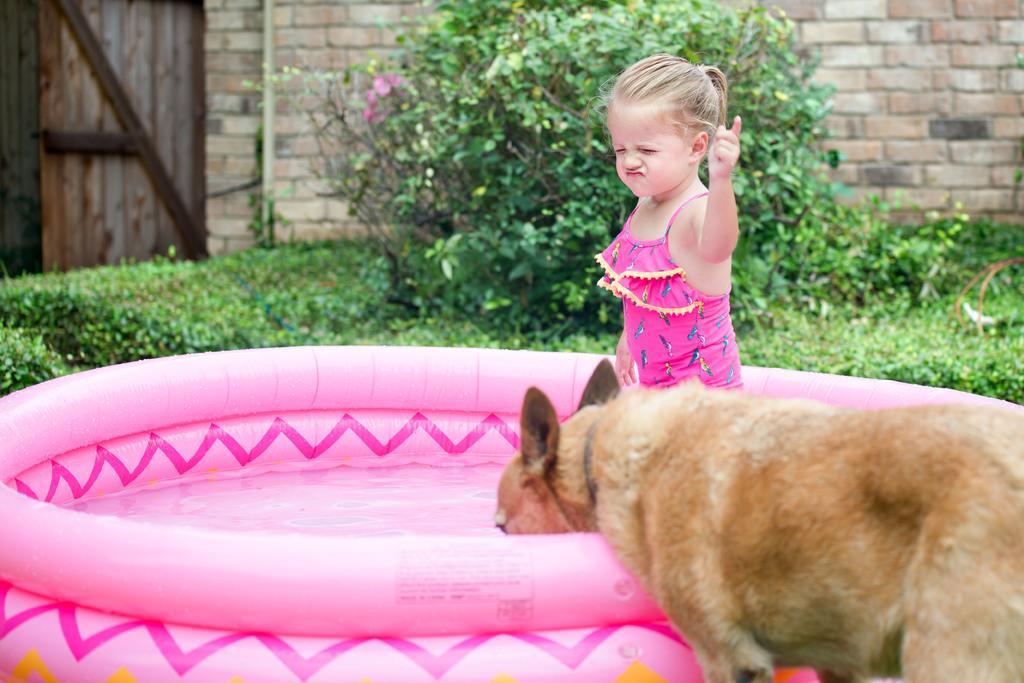Please provide a concise description of this image. This picture there is a water tub and is a small girl, there is a dog drinking water and standing over here and the background is grass, plants, a brick wall and wooden door 